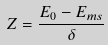Convert formula to latex. <formula><loc_0><loc_0><loc_500><loc_500>Z = \frac { E _ { 0 } - E _ { m s } } { \delta }</formula> 